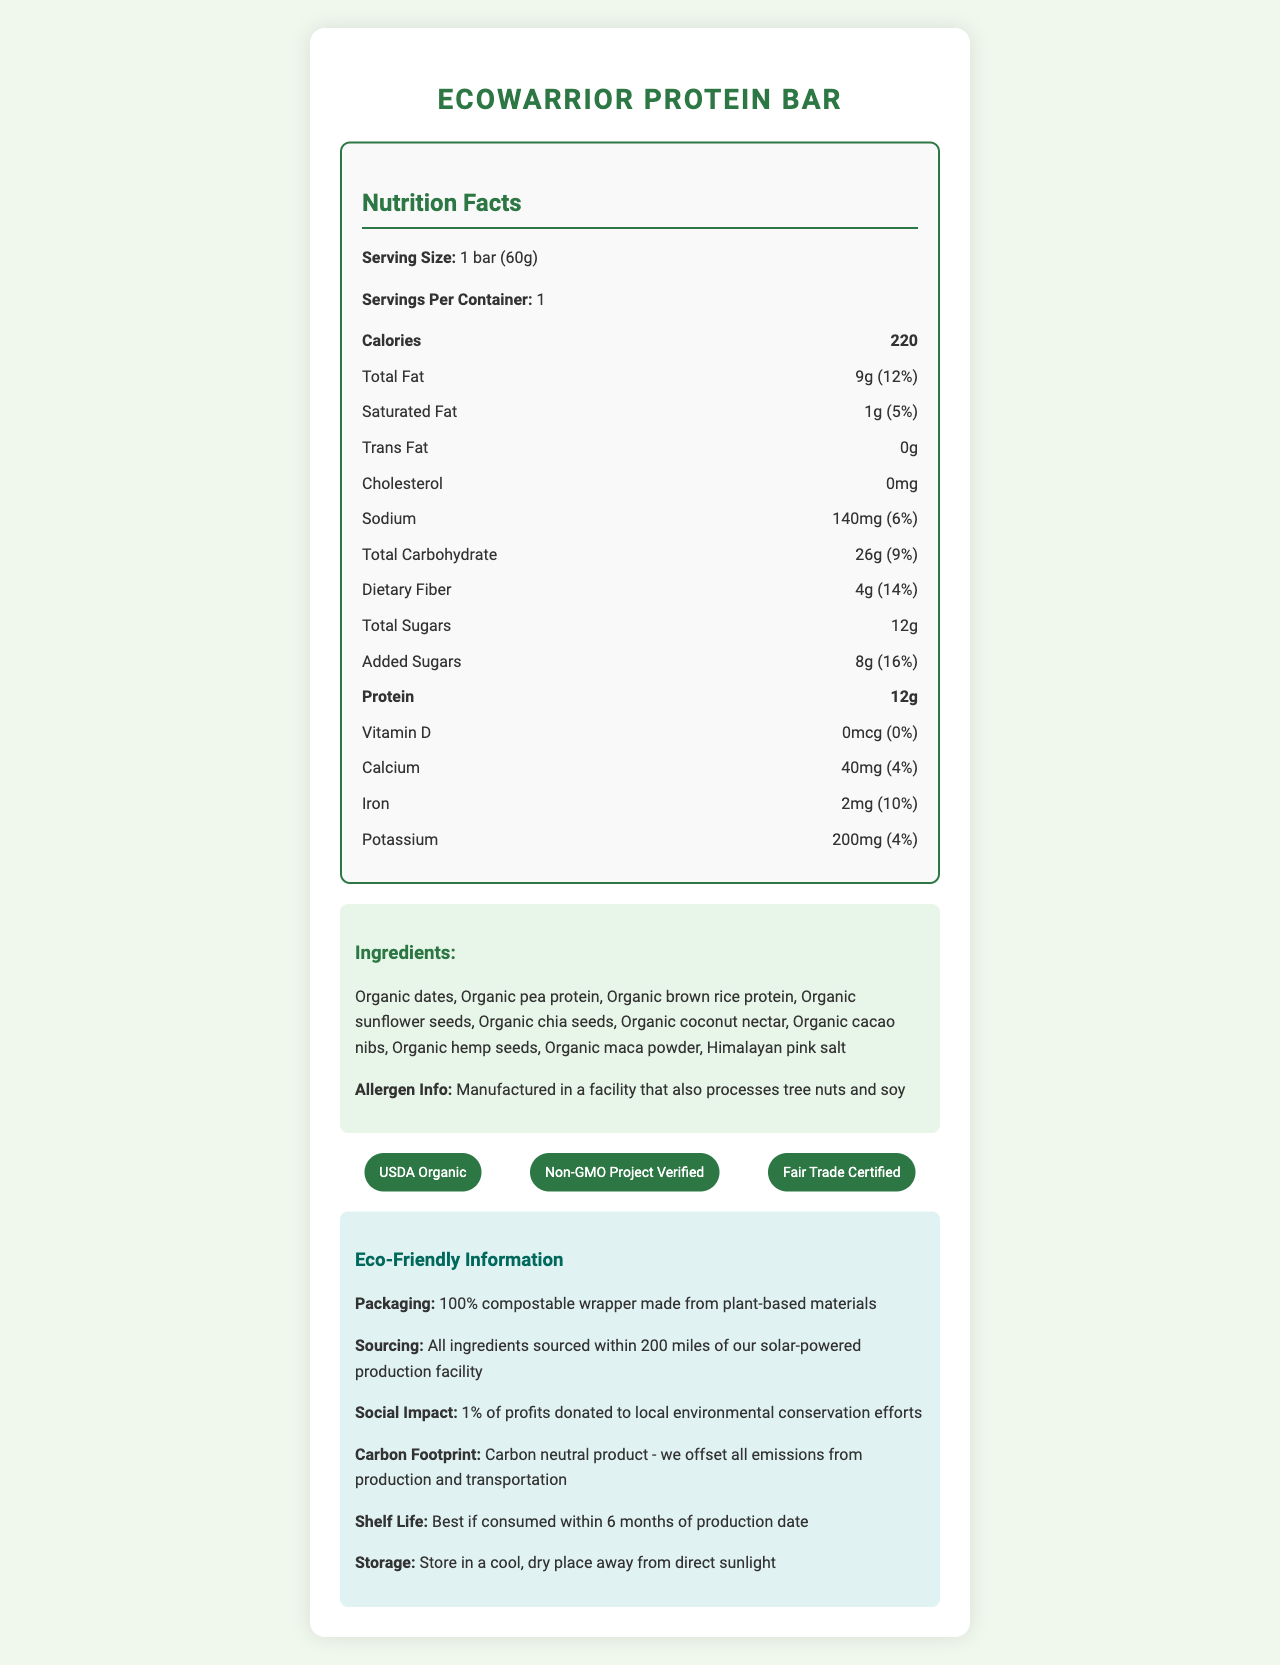what is the serving size of the EcoWarrior Protein Bar? The serving size is specifically mentioned at the start of the Nutrition Facts as "1 bar (60g)".
Answer: 1 bar (60g) How many calories are in one serving? The number of calories is given in the Nutrition Facts section where it states "Calories 220".
Answer: 220 How much protein does each bar contain? In the Nutrition Facts section, it lists "Protein 12g".
Answer: 12g What is the shelf life of the EcoWarrior Protein Bar? The shelf life is mentioned under the Eco-Friendly Information section.
Answer: Best if consumed within 6 months of production date Which certifications does the EcoWarrior Protein Bar have? These certifications are listed under the certifications section of the document.
Answer: USDA Organic, Non-GMO Project Verified, Fair Trade Certified What percentage of the daily value of iron does one bar provide? A. 4% B. 10% C. 16% The Nutrition Facts section lists the daily value of iron as "10%".
Answer: B How much dietary fiber is in one bar? A. 2g B. 4g C. 8g The dietary fiber amount is stated as "4g" in the Nutrition Facts section.
Answer: B Is there any cholesterol in the EcoWarrior Protein Bar? The Nutrition Facts list "Cholesterol 0mg", indicating there is no cholesterol.
Answer: No Is the packaging for the EcoWarrior Protein Bar environmentally friendly? The document mentions the packaging is a "100% compostable wrapper made from plant-based materials".
Answer: Yes Provide a summary of the EcoWarrior Protein Bar document. The document is a comprehensive overview of the EcoWarrior Protein Bar's nutritional content, ingredients, environmental impact, and storage guidelines, emphasizing its organic and eco-friendly attributes.
Answer: The document provides detailed nutritional information, ingredients, and eco-friendly aspects of the EcoWarrior Protein Bar. It highlights the serving size, calories, and various nutrient amounts. It lists the organic ingredients and mentions allergen info. The bar is USDA Organic, Non-GMO Project Verified, Fair Trade Certified, and comes in compostable packaging. The company sources ingredients locally and donates 1% of profits to environmental conservation. It is a carbon-neutral product, best consumed within 6 months, and should be stored properly. What type of seeds are included in the ingredients? These seeds are listed among the ingredients in the ingredients section of the document.
Answer: Sunflower seeds, chia seeds, hemp seeds What is the amount of added sugars in the bar? The Nutrition Facts section states "Added Sugars 8g".
Answer: 8g How much sodium does each bar contain in milligrams? The sodium content is listed in the Nutrition Facts as "140mg".
Answer: 140mg Where are the ingredients for the EcoWarrior Protein Bar sourced from? This information is provided in the Eco-Friendly Information section under sourcing.
Answer: Within 200 miles of our solar-powered production facility By what percentage of daily value does saturated fat contribute? A. 1% B. 5% C. 10% D. 12% The Nutrition Facts section shows saturated fat as "5%".
Answer: B What are the specific contributions of the EcoWarrior Protein Bar to social causes? The Eco-Friendly Information section states that 1% of profits are donated to environmental conservation efforts.
Answer: 1% of profits donated to local environmental conservation efforts Can we determine the exact cost of the EcoWarrior Protein Bar from this document? The document does not provide any pricing information.
Answer: Not enough information What is the carbon footprint of the EcoWarrior Protein Bar? The Eco-Friendly Information section mentions that the product is carbon neutral.
Answer: Carbon neutral product - we offset all emissions from production and transportation 